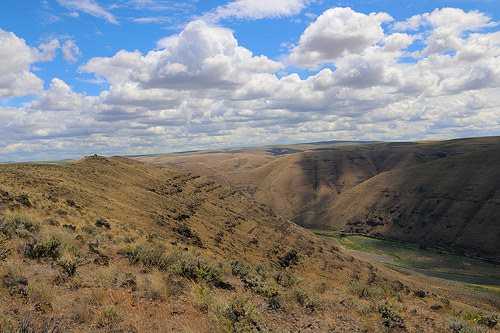<image>
Can you confirm if the sand is under the cloud? Yes. The sand is positioned underneath the cloud, with the cloud above it in the vertical space. 